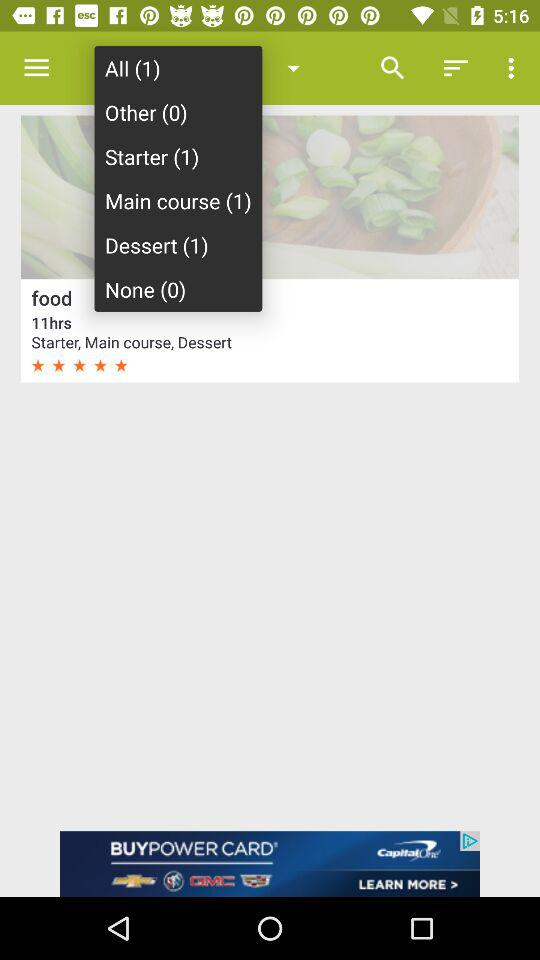What is the number of foods in strarter? The number of foods in strarter is 1. 